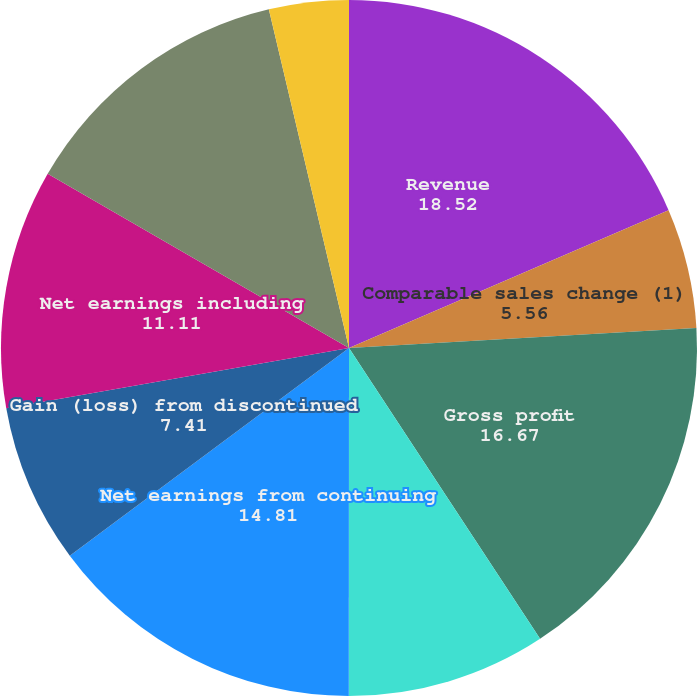Convert chart. <chart><loc_0><loc_0><loc_500><loc_500><pie_chart><fcel>Revenue<fcel>Comparable sales change (1)<fcel>Gross profit<fcel>Operating income (2)<fcel>Net earnings from continuing<fcel>Gain (loss) from discontinued<fcel>Net earnings including<fcel>Net earnings attributable to<fcel>Continuing operations<fcel>Discontinued operations<nl><fcel>18.52%<fcel>5.56%<fcel>16.67%<fcel>9.26%<fcel>14.81%<fcel>7.41%<fcel>11.11%<fcel>12.96%<fcel>3.7%<fcel>0.0%<nl></chart> 